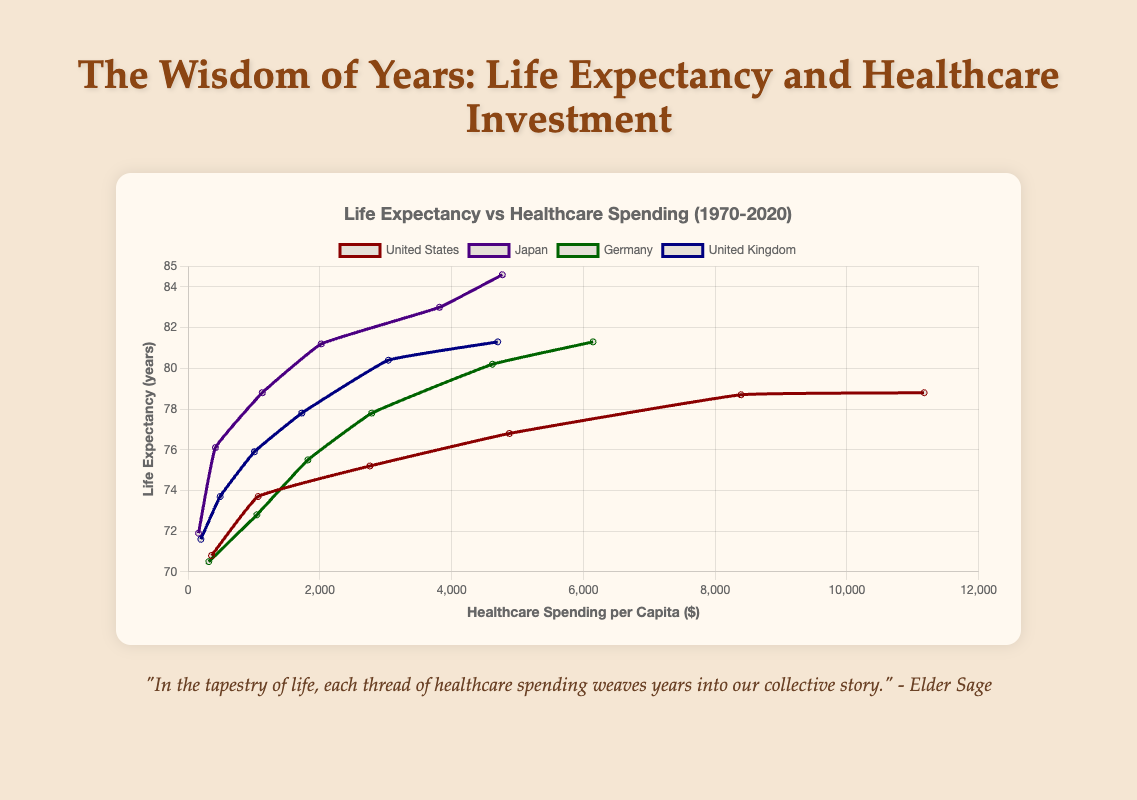What trend do we observe in healthcare spending per capita for the United States from 1970 to 2020? The data shows that healthcare spending per capita in the United States has significantly increased from $356 in 1970 to $11,172 in 2020.
Answer: Increased significantly Which country had the lowest healthcare spending per capita in 1990, and what was it? By comparing the healthcare spending across the countries in 1990, Japan had the lowest spending per capita at $1,125.
Answer: Japan, $1,125 How does the life expectancy in the United Kingdom in 2020 compare to the life expectancy in Germany in 2000? Life expectancy in the UK in 2020 was 81.3 years, higher than Germany's 77.8 years in 2000.
Answer: Higher Which country experienced the greatest increase in life expectancy from 1970 to 2020 and by how many years? Japan experienced the greatest increase, with life expectancy rising from 71.9 years in 1970 to 84.6 years in 2020, an increase of 12.7 years.
Answer: Japan, 12.7 years What was the difference in healthcare spending per capita between 1970 and 2020 for Germany? Germany's healthcare spending per capita in 1970 was $314 and $6,146 in 2020. The difference is $6,146 - $314 = $5,832.
Answer: $5,832 In which year did Germany surpass a life expectancy of 80 years? According to the data, Germany surpassed a life expectancy of 80 years in the year 2010.
Answer: 2010 Between 1970 and 2020, which country had the highest average life expectancy across all years and what was that average? To find the highest average life expectancy, we sum the life expectancies over the years for each country and divide by the number of years. Japan had the highest average life expectancy, calculated as (71.9 + 76.1 + 78.8 + 81.2 + 83.0 + 84.6) / 6 ≈ 79.3 years.
Answer: Japan, 79.3 years 